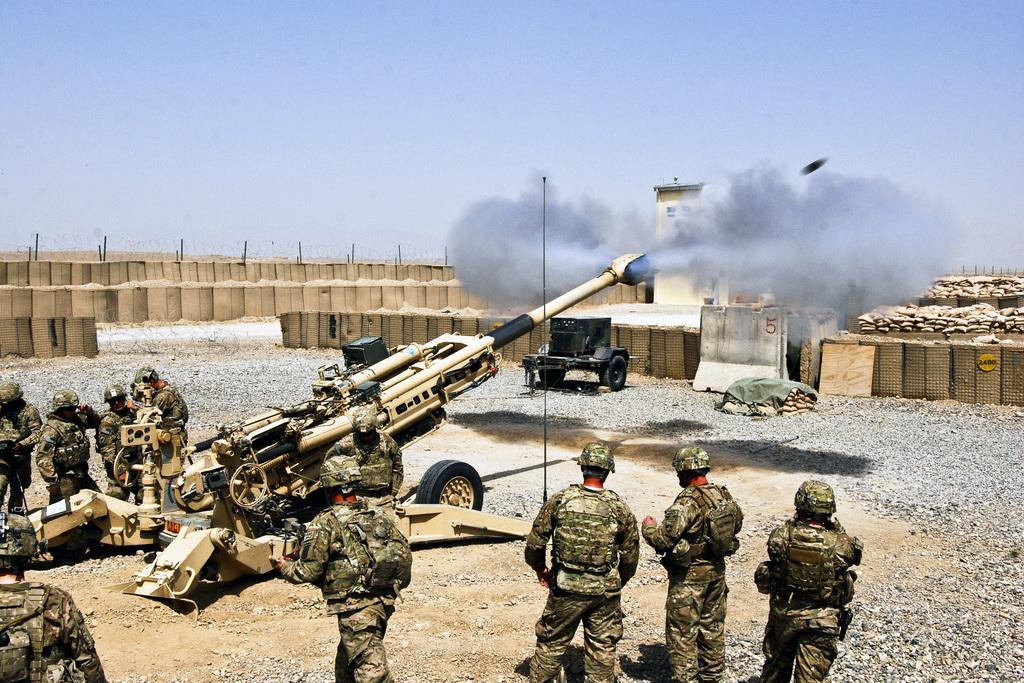What type of people can be seen in the image? There are army people standing in the image. What equipment is present in the image? There is a missile launcher in the image. What is placed on the surface in the image? There are objects placed on the surface in the image. What can be seen in the background of the image? The sky is visible in the background of the image. What type of home can be seen in the image? There is no home present in the image; it features army people and a missile launcher. What type of lumber is being used to construct the missile launcher in the image? The image does not provide information about the materials used to construct the missile launcher, and there is no lumber visible. 